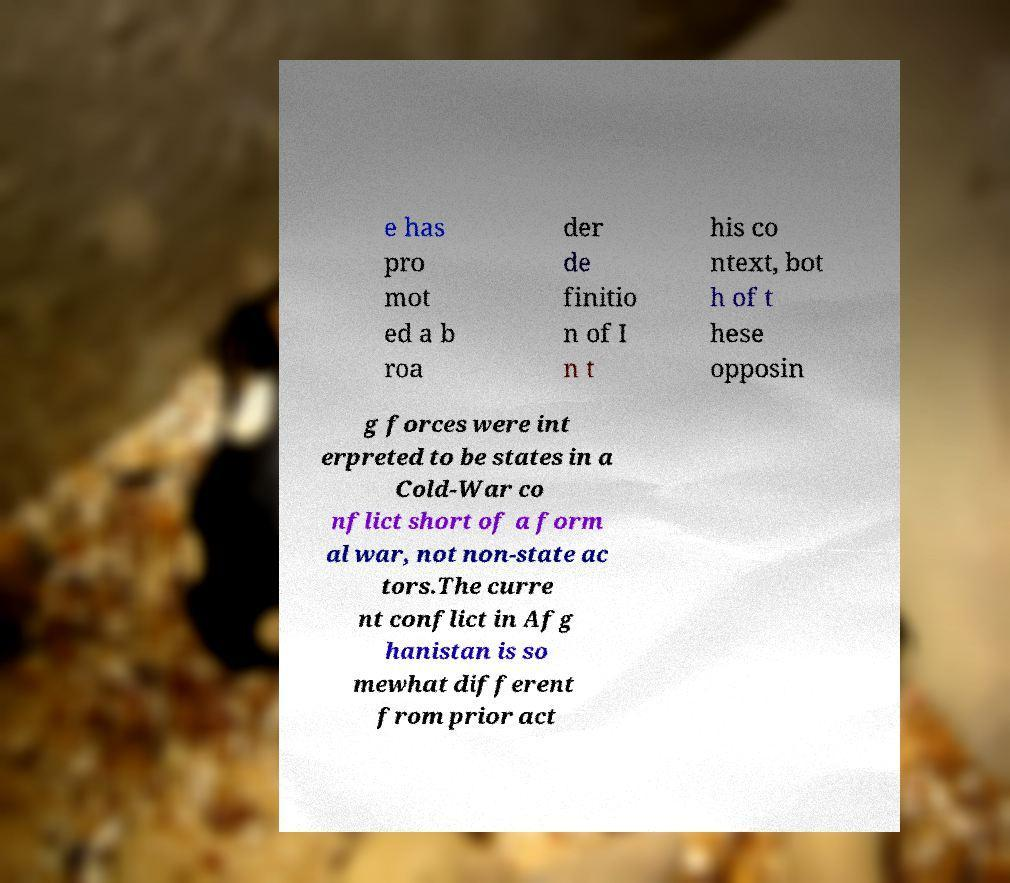For documentation purposes, I need the text within this image transcribed. Could you provide that? e has pro mot ed a b roa der de finitio n of I n t his co ntext, bot h of t hese opposin g forces were int erpreted to be states in a Cold-War co nflict short of a form al war, not non-state ac tors.The curre nt conflict in Afg hanistan is so mewhat different from prior act 